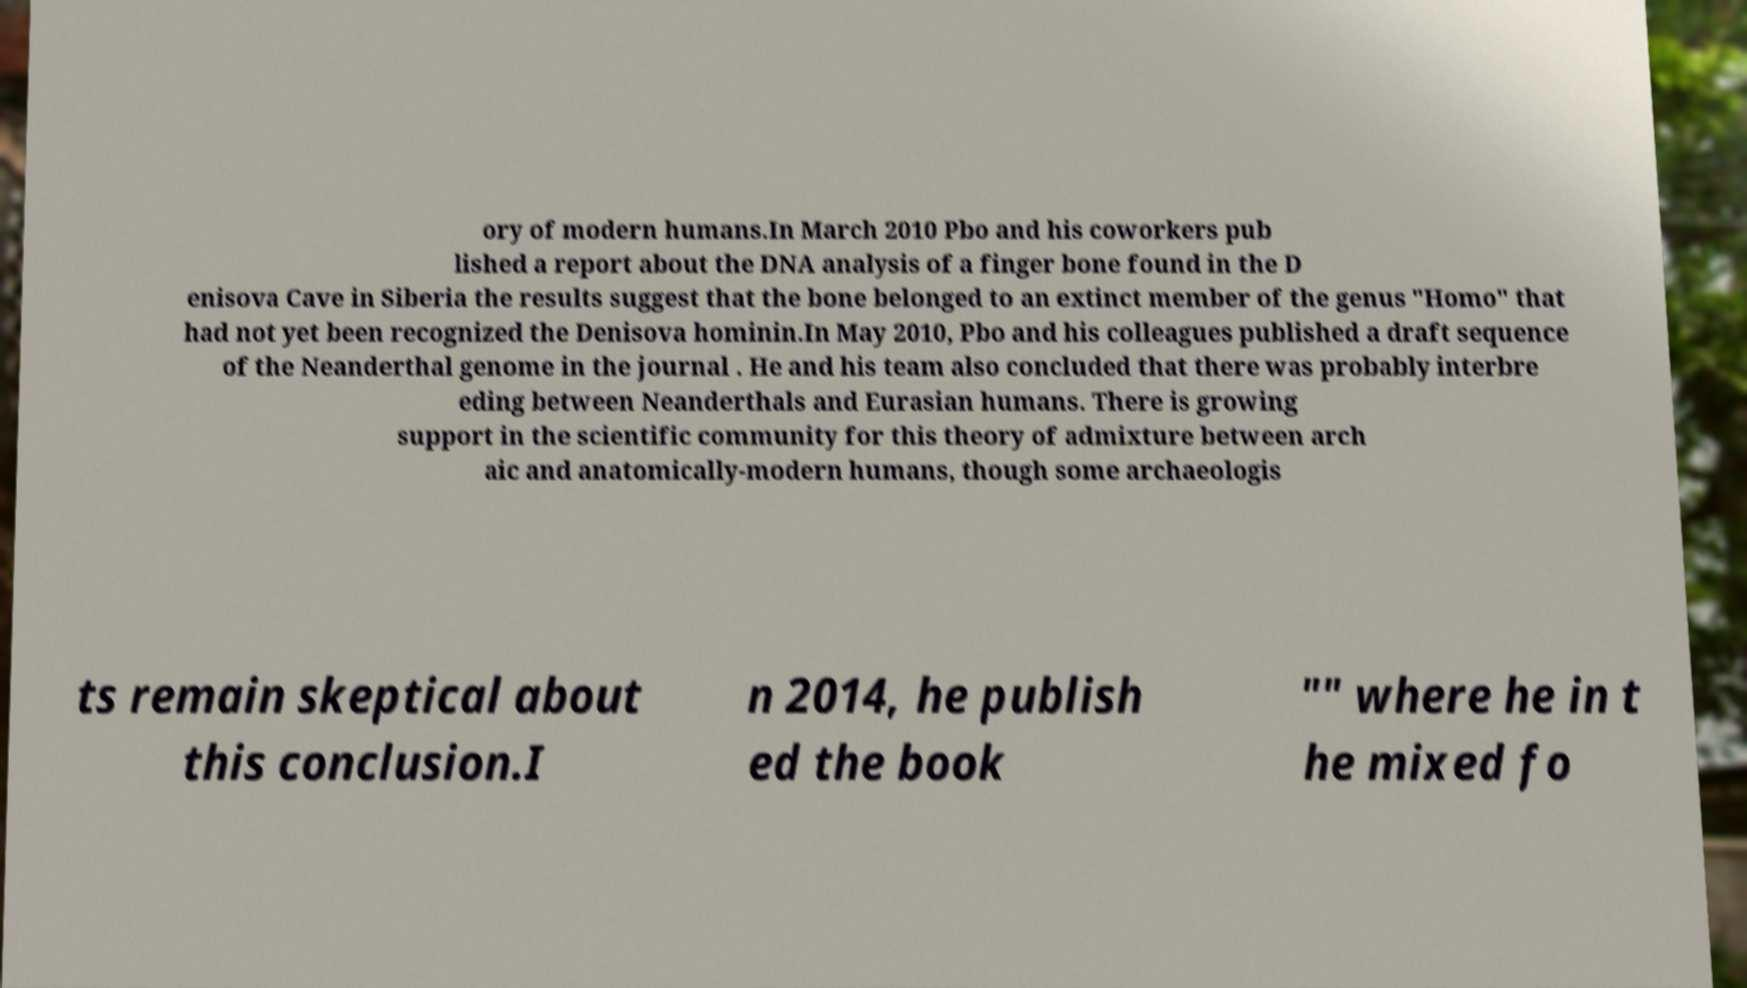Please identify and transcribe the text found in this image. ory of modern humans.In March 2010 Pbo and his coworkers pub lished a report about the DNA analysis of a finger bone found in the D enisova Cave in Siberia the results suggest that the bone belonged to an extinct member of the genus "Homo" that had not yet been recognized the Denisova hominin.In May 2010, Pbo and his colleagues published a draft sequence of the Neanderthal genome in the journal . He and his team also concluded that there was probably interbre eding between Neanderthals and Eurasian humans. There is growing support in the scientific community for this theory of admixture between arch aic and anatomically-modern humans, though some archaeologis ts remain skeptical about this conclusion.I n 2014, he publish ed the book "" where he in t he mixed fo 